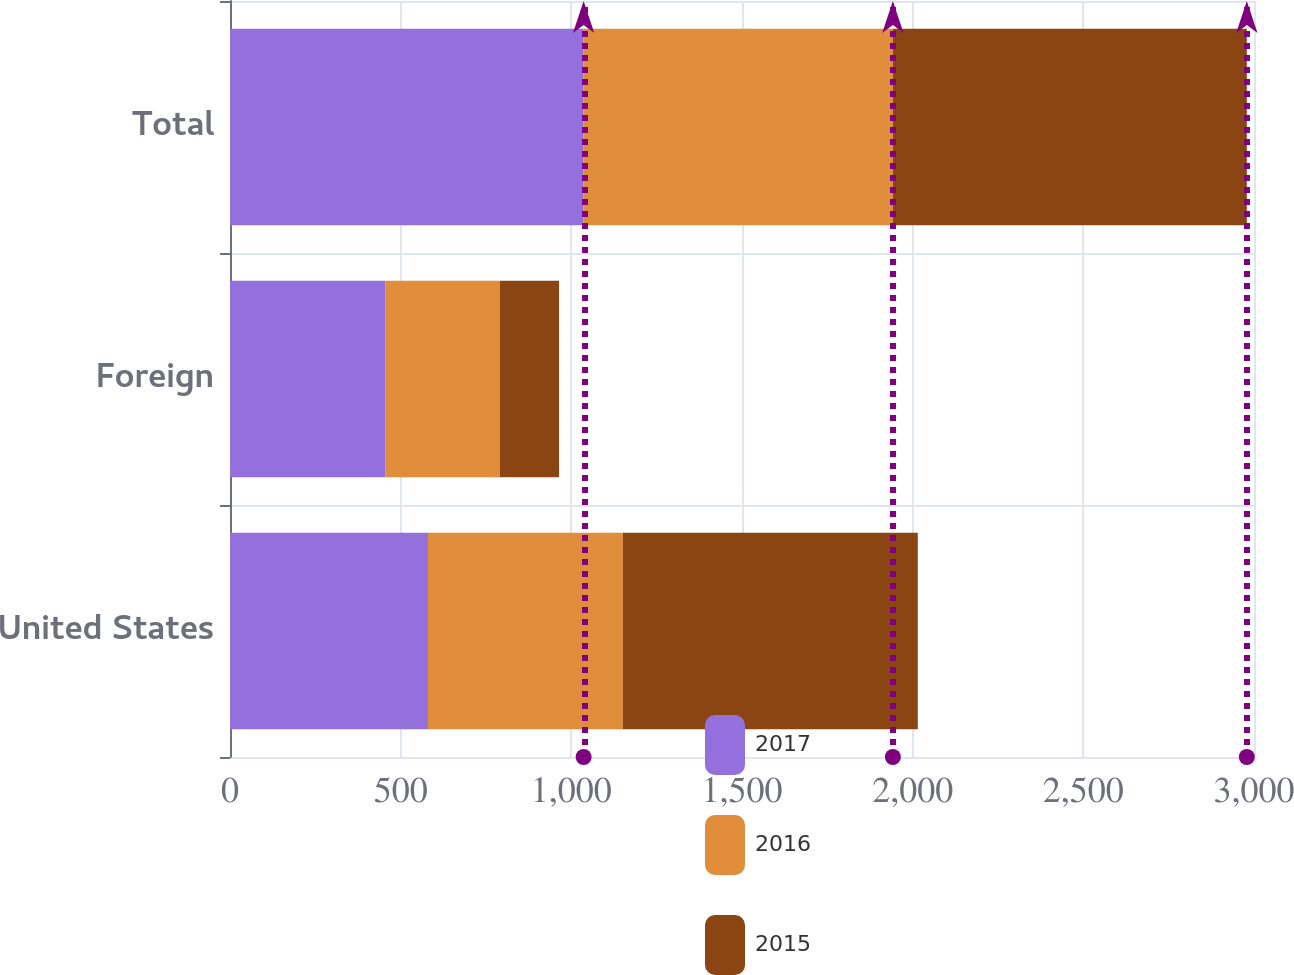Convert chart to OTSL. <chart><loc_0><loc_0><loc_500><loc_500><stacked_bar_chart><ecel><fcel>United States<fcel>Foreign<fcel>Total<nl><fcel>2017<fcel>580<fcel>456<fcel>1036<nl><fcel>2016<fcel>571<fcel>335<fcel>906<nl><fcel>2015<fcel>864<fcel>173<fcel>1037<nl></chart> 